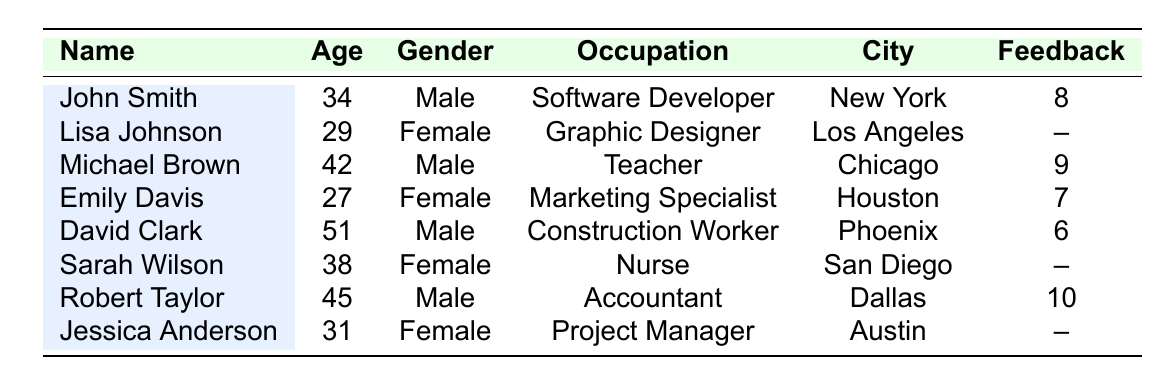What is the total number of participants listed in the attendance records? There are 8 participants listed in the records.
Answer: 8 What is the feedback score of John Smith? The feedback score of John Smith is 8, as shown in the table.
Answer: 8 How many participants attended the workshop? The table shows attendance status for each participant: John Smith, Michael Brown, Emily Davis, David Clark, and Robert Taylor are marked as 'Present', which totals to 5 attendees.
Answer: 5 Which participant has the highest feedback score? The highest feedback score in the table is 10, given to Robert Taylor.
Answer: Robert Taylor Is there any participant who gave feedback? Lisa Johnson, Sarah Wilson, and Jessica Anderson did not provide feedback, as their scores are marked as '--'. Therefore, yes, there are participants who gave feedback.
Answer: Yes What is the average age of all participants? To find the average: sum of ages (34 + 29 + 42 + 27 + 51 + 38 + 45 + 31 = 297) divided by total participants (8). The average age is 297 / 8 = 37.125.
Answer: 37.125 Which city has the most participants listed? Each city has only one participant listed in the table, so there is no city with more than one participant.
Answer: None How many female participants attended the workshop? The table shows Emily Davis is present (Female). The total number of female participants is 1.
Answer: 1 What is the difference in feedback scores between the highest and lowest? The highest score is 10 (Robert Taylor) and the lowest provided score is 6 (David Clark). The difference is 10 - 6 = 4.
Answer: 4 Which participant is the oldest? The ages of participants are: John Smith (34), Lisa Johnson (29), Michael Brown (42), Emily Davis (27), David Clark (51), Sarah Wilson (38), Robert Taylor (45), Jessica Anderson (31). David Clark is the oldest at 51 years.
Answer: David Clark If two more participants provided feedback, how many would have provided feedback? Currently, 5 participants have provided feedback, and if 2 more provide feedback, the total would be 5 + 2 = 7.
Answer: 7 